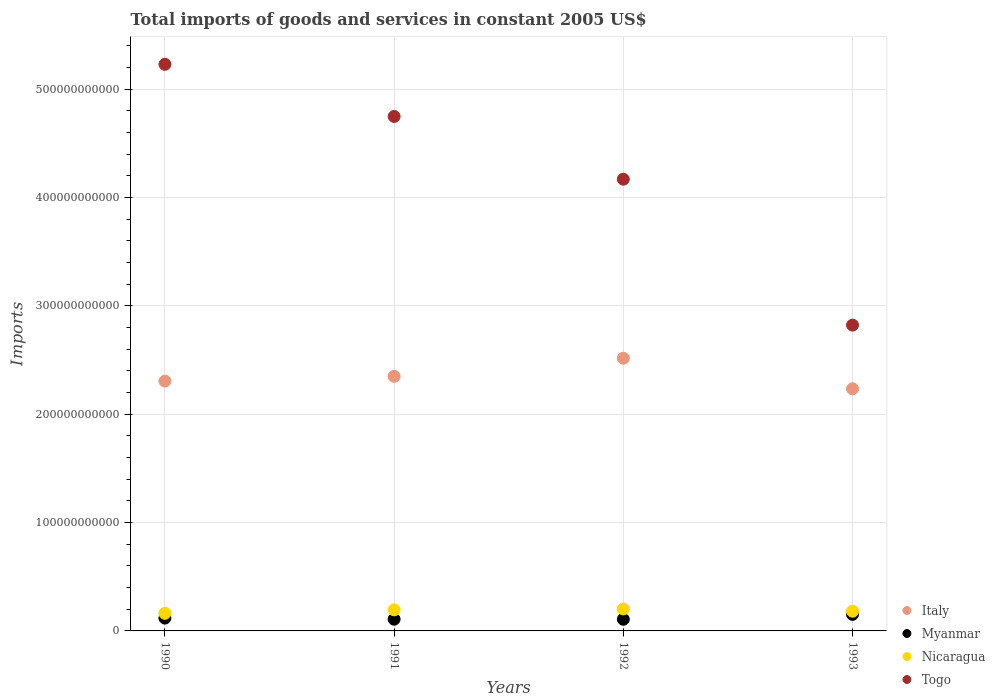How many different coloured dotlines are there?
Provide a succinct answer. 4. Is the number of dotlines equal to the number of legend labels?
Provide a succinct answer. Yes. What is the total imports of goods and services in Italy in 1992?
Ensure brevity in your answer.  2.52e+11. Across all years, what is the maximum total imports of goods and services in Myanmar?
Ensure brevity in your answer.  1.52e+1. Across all years, what is the minimum total imports of goods and services in Nicaragua?
Offer a terse response. 1.62e+1. What is the total total imports of goods and services in Nicaragua in the graph?
Provide a succinct answer. 7.40e+1. What is the difference between the total imports of goods and services in Myanmar in 1990 and that in 1992?
Your answer should be very brief. 1.08e+09. What is the difference between the total imports of goods and services in Togo in 1991 and the total imports of goods and services in Myanmar in 1992?
Provide a succinct answer. 4.64e+11. What is the average total imports of goods and services in Myanmar per year?
Provide a short and direct response. 1.22e+1. In the year 1993, what is the difference between the total imports of goods and services in Italy and total imports of goods and services in Togo?
Your response must be concise. -5.88e+1. What is the ratio of the total imports of goods and services in Italy in 1991 to that in 1993?
Offer a very short reply. 1.05. Is the total imports of goods and services in Italy in 1991 less than that in 1992?
Keep it short and to the point. Yes. What is the difference between the highest and the second highest total imports of goods and services in Myanmar?
Give a very brief answer. 3.42e+09. What is the difference between the highest and the lowest total imports of goods and services in Togo?
Offer a terse response. 2.41e+11. Is it the case that in every year, the sum of the total imports of goods and services in Togo and total imports of goods and services in Myanmar  is greater than the sum of total imports of goods and services in Nicaragua and total imports of goods and services in Italy?
Your answer should be compact. No. Is it the case that in every year, the sum of the total imports of goods and services in Nicaragua and total imports of goods and services in Myanmar  is greater than the total imports of goods and services in Italy?
Your answer should be compact. No. Does the total imports of goods and services in Togo monotonically increase over the years?
Offer a terse response. No. How many dotlines are there?
Ensure brevity in your answer.  4. How many years are there in the graph?
Make the answer very short. 4. What is the difference between two consecutive major ticks on the Y-axis?
Provide a succinct answer. 1.00e+11. Does the graph contain any zero values?
Provide a short and direct response. No. How are the legend labels stacked?
Ensure brevity in your answer.  Vertical. What is the title of the graph?
Keep it short and to the point. Total imports of goods and services in constant 2005 US$. Does "Low & middle income" appear as one of the legend labels in the graph?
Offer a terse response. No. What is the label or title of the Y-axis?
Provide a succinct answer. Imports. What is the Imports of Italy in 1990?
Make the answer very short. 2.31e+11. What is the Imports of Myanmar in 1990?
Keep it short and to the point. 1.18e+1. What is the Imports of Nicaragua in 1990?
Ensure brevity in your answer.  1.62e+1. What is the Imports of Togo in 1990?
Ensure brevity in your answer.  5.23e+11. What is the Imports in Italy in 1991?
Offer a very short reply. 2.35e+11. What is the Imports of Myanmar in 1991?
Offer a very short reply. 1.08e+1. What is the Imports in Nicaragua in 1991?
Your response must be concise. 1.94e+1. What is the Imports of Togo in 1991?
Provide a succinct answer. 4.75e+11. What is the Imports in Italy in 1992?
Keep it short and to the point. 2.52e+11. What is the Imports in Myanmar in 1992?
Keep it short and to the point. 1.07e+1. What is the Imports in Nicaragua in 1992?
Your answer should be compact. 2.03e+1. What is the Imports of Togo in 1992?
Give a very brief answer. 4.17e+11. What is the Imports in Italy in 1993?
Offer a terse response. 2.23e+11. What is the Imports in Myanmar in 1993?
Provide a succinct answer. 1.52e+1. What is the Imports of Nicaragua in 1993?
Your response must be concise. 1.81e+1. What is the Imports of Togo in 1993?
Your response must be concise. 2.82e+11. Across all years, what is the maximum Imports of Italy?
Provide a succinct answer. 2.52e+11. Across all years, what is the maximum Imports in Myanmar?
Provide a succinct answer. 1.52e+1. Across all years, what is the maximum Imports of Nicaragua?
Your response must be concise. 2.03e+1. Across all years, what is the maximum Imports of Togo?
Offer a very short reply. 5.23e+11. Across all years, what is the minimum Imports in Italy?
Your answer should be very brief. 2.23e+11. Across all years, what is the minimum Imports in Myanmar?
Provide a succinct answer. 1.07e+1. Across all years, what is the minimum Imports of Nicaragua?
Ensure brevity in your answer.  1.62e+1. Across all years, what is the minimum Imports of Togo?
Your answer should be compact. 2.82e+11. What is the total Imports of Italy in the graph?
Provide a short and direct response. 9.40e+11. What is the total Imports of Myanmar in the graph?
Keep it short and to the point. 4.86e+1. What is the total Imports of Nicaragua in the graph?
Provide a succinct answer. 7.40e+1. What is the total Imports of Togo in the graph?
Keep it short and to the point. 1.70e+12. What is the difference between the Imports of Italy in 1990 and that in 1991?
Offer a terse response. -4.36e+09. What is the difference between the Imports in Myanmar in 1990 and that in 1991?
Make the answer very short. 1.02e+09. What is the difference between the Imports in Nicaragua in 1990 and that in 1991?
Offer a very short reply. -3.20e+09. What is the difference between the Imports in Togo in 1990 and that in 1991?
Your response must be concise. 4.81e+1. What is the difference between the Imports of Italy in 1990 and that in 1992?
Offer a very short reply. -2.11e+1. What is the difference between the Imports of Myanmar in 1990 and that in 1992?
Offer a terse response. 1.08e+09. What is the difference between the Imports of Nicaragua in 1990 and that in 1992?
Provide a succinct answer. -4.04e+09. What is the difference between the Imports in Togo in 1990 and that in 1992?
Offer a very short reply. 1.06e+11. What is the difference between the Imports of Italy in 1990 and that in 1993?
Ensure brevity in your answer.  7.09e+09. What is the difference between the Imports of Myanmar in 1990 and that in 1993?
Your response must be concise. -3.42e+09. What is the difference between the Imports in Nicaragua in 1990 and that in 1993?
Make the answer very short. -1.92e+09. What is the difference between the Imports of Togo in 1990 and that in 1993?
Your response must be concise. 2.41e+11. What is the difference between the Imports of Italy in 1991 and that in 1992?
Your answer should be compact. -1.67e+1. What is the difference between the Imports in Myanmar in 1991 and that in 1992?
Your response must be concise. 5.08e+07. What is the difference between the Imports of Nicaragua in 1991 and that in 1992?
Keep it short and to the point. -8.32e+08. What is the difference between the Imports of Togo in 1991 and that in 1992?
Your answer should be compact. 5.79e+1. What is the difference between the Imports in Italy in 1991 and that in 1993?
Provide a succinct answer. 1.15e+1. What is the difference between the Imports in Myanmar in 1991 and that in 1993?
Offer a very short reply. -4.44e+09. What is the difference between the Imports in Nicaragua in 1991 and that in 1993?
Offer a terse response. 1.29e+09. What is the difference between the Imports in Togo in 1991 and that in 1993?
Your response must be concise. 1.93e+11. What is the difference between the Imports in Italy in 1992 and that in 1993?
Your answer should be very brief. 2.82e+1. What is the difference between the Imports of Myanmar in 1992 and that in 1993?
Provide a short and direct response. -4.49e+09. What is the difference between the Imports of Nicaragua in 1992 and that in 1993?
Provide a succinct answer. 2.12e+09. What is the difference between the Imports of Togo in 1992 and that in 1993?
Offer a very short reply. 1.35e+11. What is the difference between the Imports of Italy in 1990 and the Imports of Myanmar in 1991?
Make the answer very short. 2.20e+11. What is the difference between the Imports of Italy in 1990 and the Imports of Nicaragua in 1991?
Your answer should be compact. 2.11e+11. What is the difference between the Imports of Italy in 1990 and the Imports of Togo in 1991?
Keep it short and to the point. -2.44e+11. What is the difference between the Imports in Myanmar in 1990 and the Imports in Nicaragua in 1991?
Your response must be concise. -7.60e+09. What is the difference between the Imports of Myanmar in 1990 and the Imports of Togo in 1991?
Your answer should be compact. -4.63e+11. What is the difference between the Imports in Nicaragua in 1990 and the Imports in Togo in 1991?
Keep it short and to the point. -4.59e+11. What is the difference between the Imports of Italy in 1990 and the Imports of Myanmar in 1992?
Offer a terse response. 2.20e+11. What is the difference between the Imports in Italy in 1990 and the Imports in Nicaragua in 1992?
Your answer should be very brief. 2.10e+11. What is the difference between the Imports in Italy in 1990 and the Imports in Togo in 1992?
Keep it short and to the point. -1.86e+11. What is the difference between the Imports in Myanmar in 1990 and the Imports in Nicaragua in 1992?
Offer a very short reply. -8.44e+09. What is the difference between the Imports in Myanmar in 1990 and the Imports in Togo in 1992?
Your response must be concise. -4.05e+11. What is the difference between the Imports in Nicaragua in 1990 and the Imports in Togo in 1992?
Keep it short and to the point. -4.01e+11. What is the difference between the Imports in Italy in 1990 and the Imports in Myanmar in 1993?
Your response must be concise. 2.15e+11. What is the difference between the Imports of Italy in 1990 and the Imports of Nicaragua in 1993?
Your answer should be compact. 2.12e+11. What is the difference between the Imports in Italy in 1990 and the Imports in Togo in 1993?
Your answer should be compact. -5.17e+1. What is the difference between the Imports of Myanmar in 1990 and the Imports of Nicaragua in 1993?
Your response must be concise. -6.32e+09. What is the difference between the Imports of Myanmar in 1990 and the Imports of Togo in 1993?
Your answer should be compact. -2.70e+11. What is the difference between the Imports of Nicaragua in 1990 and the Imports of Togo in 1993?
Offer a very short reply. -2.66e+11. What is the difference between the Imports of Italy in 1991 and the Imports of Myanmar in 1992?
Give a very brief answer. 2.24e+11. What is the difference between the Imports in Italy in 1991 and the Imports in Nicaragua in 1992?
Make the answer very short. 2.15e+11. What is the difference between the Imports of Italy in 1991 and the Imports of Togo in 1992?
Your answer should be very brief. -1.82e+11. What is the difference between the Imports of Myanmar in 1991 and the Imports of Nicaragua in 1992?
Your response must be concise. -9.46e+09. What is the difference between the Imports in Myanmar in 1991 and the Imports in Togo in 1992?
Give a very brief answer. -4.06e+11. What is the difference between the Imports in Nicaragua in 1991 and the Imports in Togo in 1992?
Provide a short and direct response. -3.97e+11. What is the difference between the Imports in Italy in 1991 and the Imports in Myanmar in 1993?
Provide a succinct answer. 2.20e+11. What is the difference between the Imports in Italy in 1991 and the Imports in Nicaragua in 1993?
Your response must be concise. 2.17e+11. What is the difference between the Imports in Italy in 1991 and the Imports in Togo in 1993?
Give a very brief answer. -4.73e+1. What is the difference between the Imports of Myanmar in 1991 and the Imports of Nicaragua in 1993?
Provide a succinct answer. -7.34e+09. What is the difference between the Imports in Myanmar in 1991 and the Imports in Togo in 1993?
Provide a succinct answer. -2.71e+11. What is the difference between the Imports in Nicaragua in 1991 and the Imports in Togo in 1993?
Make the answer very short. -2.63e+11. What is the difference between the Imports of Italy in 1992 and the Imports of Myanmar in 1993?
Make the answer very short. 2.36e+11. What is the difference between the Imports in Italy in 1992 and the Imports in Nicaragua in 1993?
Ensure brevity in your answer.  2.33e+11. What is the difference between the Imports of Italy in 1992 and the Imports of Togo in 1993?
Your response must be concise. -3.06e+1. What is the difference between the Imports of Myanmar in 1992 and the Imports of Nicaragua in 1993?
Provide a short and direct response. -7.39e+09. What is the difference between the Imports of Myanmar in 1992 and the Imports of Togo in 1993?
Your response must be concise. -2.71e+11. What is the difference between the Imports in Nicaragua in 1992 and the Imports in Togo in 1993?
Give a very brief answer. -2.62e+11. What is the average Imports of Italy per year?
Keep it short and to the point. 2.35e+11. What is the average Imports in Myanmar per year?
Your answer should be compact. 1.22e+1. What is the average Imports in Nicaragua per year?
Keep it short and to the point. 1.85e+1. What is the average Imports in Togo per year?
Offer a very short reply. 4.24e+11. In the year 1990, what is the difference between the Imports of Italy and Imports of Myanmar?
Offer a very short reply. 2.19e+11. In the year 1990, what is the difference between the Imports in Italy and Imports in Nicaragua?
Your answer should be very brief. 2.14e+11. In the year 1990, what is the difference between the Imports in Italy and Imports in Togo?
Make the answer very short. -2.92e+11. In the year 1990, what is the difference between the Imports in Myanmar and Imports in Nicaragua?
Your answer should be very brief. -4.40e+09. In the year 1990, what is the difference between the Imports in Myanmar and Imports in Togo?
Provide a succinct answer. -5.11e+11. In the year 1990, what is the difference between the Imports in Nicaragua and Imports in Togo?
Your answer should be compact. -5.07e+11. In the year 1991, what is the difference between the Imports of Italy and Imports of Myanmar?
Give a very brief answer. 2.24e+11. In the year 1991, what is the difference between the Imports of Italy and Imports of Nicaragua?
Keep it short and to the point. 2.15e+11. In the year 1991, what is the difference between the Imports of Italy and Imports of Togo?
Your answer should be compact. -2.40e+11. In the year 1991, what is the difference between the Imports of Myanmar and Imports of Nicaragua?
Keep it short and to the point. -8.63e+09. In the year 1991, what is the difference between the Imports in Myanmar and Imports in Togo?
Offer a very short reply. -4.64e+11. In the year 1991, what is the difference between the Imports of Nicaragua and Imports of Togo?
Your answer should be compact. -4.55e+11. In the year 1992, what is the difference between the Imports in Italy and Imports in Myanmar?
Make the answer very short. 2.41e+11. In the year 1992, what is the difference between the Imports in Italy and Imports in Nicaragua?
Offer a very short reply. 2.31e+11. In the year 1992, what is the difference between the Imports in Italy and Imports in Togo?
Offer a very short reply. -1.65e+11. In the year 1992, what is the difference between the Imports in Myanmar and Imports in Nicaragua?
Your answer should be compact. -9.51e+09. In the year 1992, what is the difference between the Imports in Myanmar and Imports in Togo?
Make the answer very short. -4.06e+11. In the year 1992, what is the difference between the Imports in Nicaragua and Imports in Togo?
Your response must be concise. -3.97e+11. In the year 1993, what is the difference between the Imports in Italy and Imports in Myanmar?
Your answer should be very brief. 2.08e+11. In the year 1993, what is the difference between the Imports of Italy and Imports of Nicaragua?
Your answer should be compact. 2.05e+11. In the year 1993, what is the difference between the Imports in Italy and Imports in Togo?
Ensure brevity in your answer.  -5.88e+1. In the year 1993, what is the difference between the Imports in Myanmar and Imports in Nicaragua?
Ensure brevity in your answer.  -2.90e+09. In the year 1993, what is the difference between the Imports of Myanmar and Imports of Togo?
Your response must be concise. -2.67e+11. In the year 1993, what is the difference between the Imports of Nicaragua and Imports of Togo?
Give a very brief answer. -2.64e+11. What is the ratio of the Imports of Italy in 1990 to that in 1991?
Keep it short and to the point. 0.98. What is the ratio of the Imports of Myanmar in 1990 to that in 1991?
Provide a short and direct response. 1.09. What is the ratio of the Imports in Nicaragua in 1990 to that in 1991?
Offer a terse response. 0.84. What is the ratio of the Imports in Togo in 1990 to that in 1991?
Give a very brief answer. 1.1. What is the ratio of the Imports of Italy in 1990 to that in 1992?
Your answer should be very brief. 0.92. What is the ratio of the Imports of Myanmar in 1990 to that in 1992?
Your answer should be compact. 1.1. What is the ratio of the Imports in Nicaragua in 1990 to that in 1992?
Make the answer very short. 0.8. What is the ratio of the Imports of Togo in 1990 to that in 1992?
Your response must be concise. 1.25. What is the ratio of the Imports in Italy in 1990 to that in 1993?
Offer a very short reply. 1.03. What is the ratio of the Imports in Myanmar in 1990 to that in 1993?
Your response must be concise. 0.78. What is the ratio of the Imports in Nicaragua in 1990 to that in 1993?
Ensure brevity in your answer.  0.89. What is the ratio of the Imports of Togo in 1990 to that in 1993?
Make the answer very short. 1.85. What is the ratio of the Imports of Italy in 1991 to that in 1992?
Provide a short and direct response. 0.93. What is the ratio of the Imports in Nicaragua in 1991 to that in 1992?
Ensure brevity in your answer.  0.96. What is the ratio of the Imports in Togo in 1991 to that in 1992?
Your answer should be very brief. 1.14. What is the ratio of the Imports in Italy in 1991 to that in 1993?
Provide a short and direct response. 1.05. What is the ratio of the Imports of Myanmar in 1991 to that in 1993?
Give a very brief answer. 0.71. What is the ratio of the Imports in Nicaragua in 1991 to that in 1993?
Give a very brief answer. 1.07. What is the ratio of the Imports in Togo in 1991 to that in 1993?
Provide a short and direct response. 1.68. What is the ratio of the Imports in Italy in 1992 to that in 1993?
Keep it short and to the point. 1.13. What is the ratio of the Imports in Myanmar in 1992 to that in 1993?
Your response must be concise. 0.71. What is the ratio of the Imports in Nicaragua in 1992 to that in 1993?
Give a very brief answer. 1.12. What is the ratio of the Imports of Togo in 1992 to that in 1993?
Make the answer very short. 1.48. What is the difference between the highest and the second highest Imports in Italy?
Your response must be concise. 1.67e+1. What is the difference between the highest and the second highest Imports of Myanmar?
Provide a short and direct response. 3.42e+09. What is the difference between the highest and the second highest Imports of Nicaragua?
Your answer should be very brief. 8.32e+08. What is the difference between the highest and the second highest Imports of Togo?
Your answer should be very brief. 4.81e+1. What is the difference between the highest and the lowest Imports of Italy?
Your answer should be very brief. 2.82e+1. What is the difference between the highest and the lowest Imports in Myanmar?
Offer a terse response. 4.49e+09. What is the difference between the highest and the lowest Imports of Nicaragua?
Give a very brief answer. 4.04e+09. What is the difference between the highest and the lowest Imports in Togo?
Your answer should be compact. 2.41e+11. 